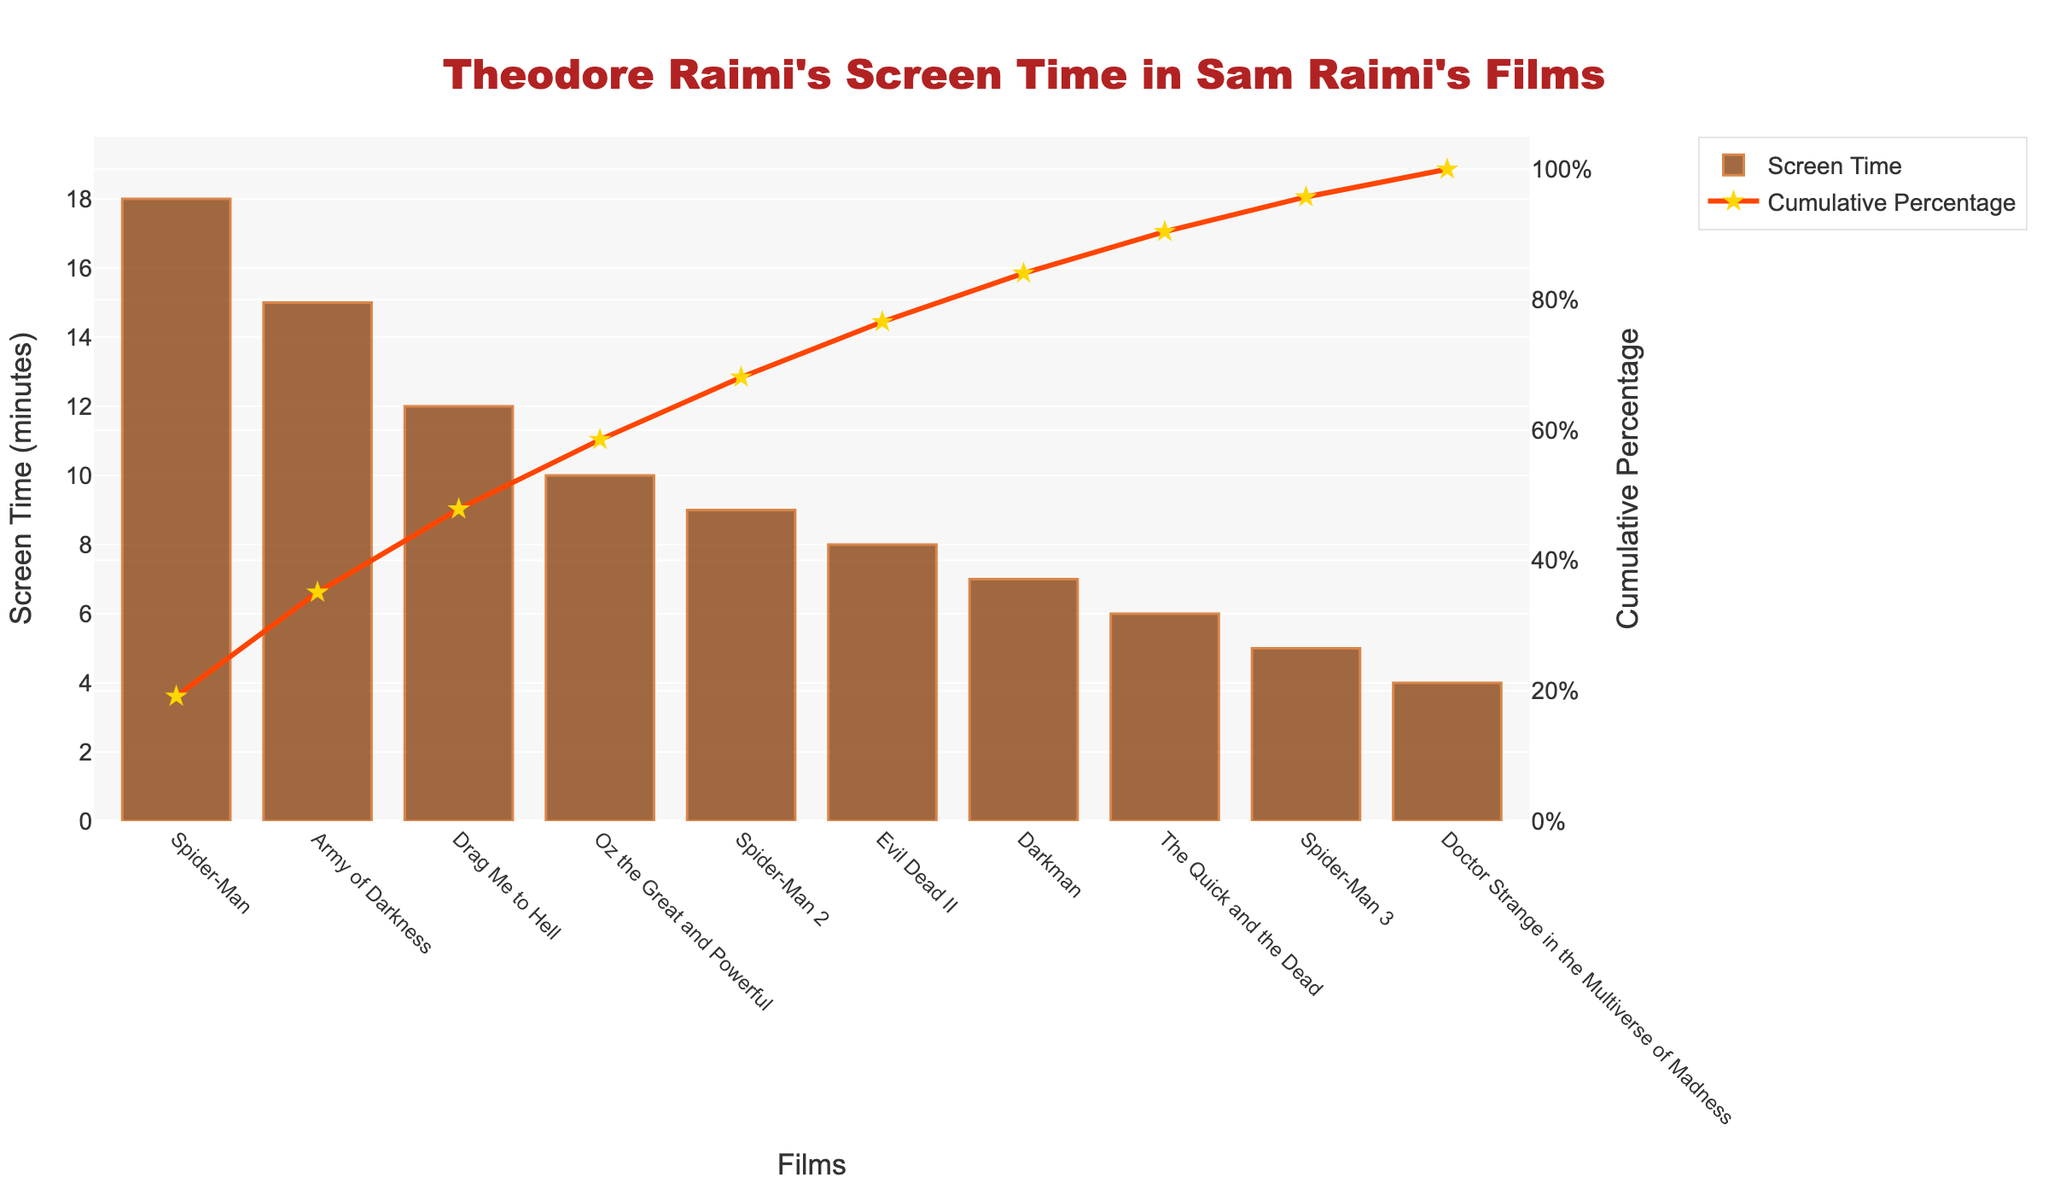What is the title of the figure? The title is displayed at the top of the chart. It is written in large, bold red text.
Answer: Theodore Raimi's Screen Time in Sam Raimi's Films Which film has the highest screen time for Theodore Raimi? Look at the bar with the highest value. It is the first bar on the left.
Answer: Spider-Man What is the cumulative percentage of Theodore Raimi's screen time after "Army of Darkness"? Add the cumulative percentage values for "Spider-Man" and "Army of Darkness" as shown by the line chart. ("Spider-Man" cumulative percentage + "Army of Darkness" incremental percentage).
Answer: 40% What is the color of the bars in the chart? The color of the bars can be identified from the visual information, predominantly brownish-red hues.
Answer: Brown What is the cumulative percentage after the first three films? Sum the cumulative percentages of "Spider-Man," "Army of Darkness," and "Drag Me to Hell" based on the line chart.
Answer: 66.67% Which films have cumulative percentages greater than 50%? Look at the cumulative percentage values along the orange line and find the corresponding films.
Answer: "Spider-Man", "Army of Darkness", "Drag Me to Hell", "Oz the Great and Powerful" What is the difference in screen time between "Spider-Man" and "Spider-Man 2"? Subtract the screen time of "Spider-Man 2" from "Spider-Man."
Answer: 9 minutes How many minutes of screen time does Theodore Raimi have in total in Sam Raimi's films? Sum the screen times of all films shown as bars in the chart.
Answer: 94 minutes Which film has the least screen time for Theodore Raimi? Identify the shortest bar in the chart.
Answer: Doctor Strange in the Multiverse of Madness What is the cumulative percentage after all films are counted? The cumulative percentage after all films should be 100% as shown at the end of the orange line chart.
Answer: 100% 